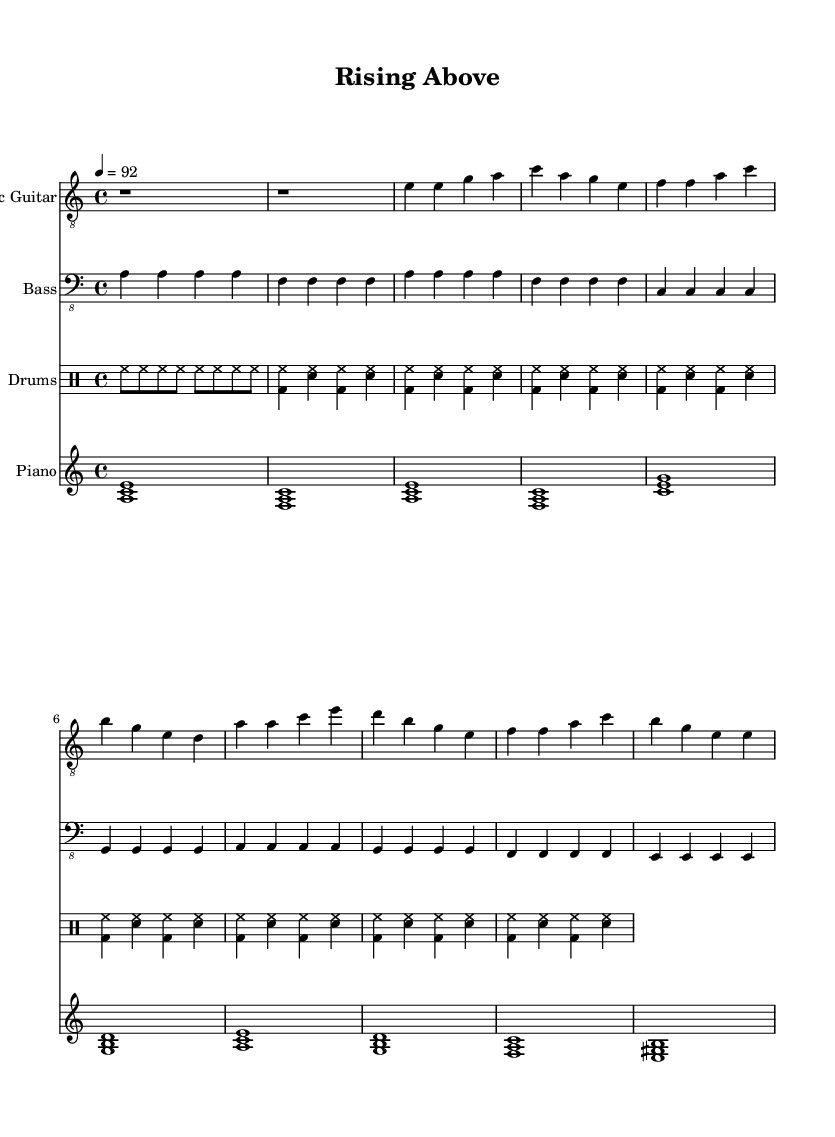What is the key signature of this music? The key signature appears to be A minor, indicated by the absence of sharps and flats, which is characteristic of the relative minor of C major.
Answer: A minor What is the time signature of this piece? The time signature shown in the sheet music is 4/4, which is indicated right at the beginning of the score. This means there are four beats per measure.
Answer: 4/4 What is the tempo marking for this composition? The tempo marking specifies a speed of quarter note equals 92, which is shown in the tempo indication at the beginning of the score.
Answer: 92 How many measures are in the chorus section? By examining the sheet music, the chorus section consists of four measures, as indicated by the groupings of notes under the chorus label.
Answer: 4 What instruments are involved in this arrangement? The sheet music specifies four instruments: Electric Guitar, Bass, Drums, and Piano, as noted in the score headers.
Answer: Electric Guitar, Bass, Drums, Piano How does the bass line in the verse relate to the overall theme? In the verse, the bass line provides a steady foundation using repeated patterns and notes that lead into the contrasting chorus, enhancing the themes of resilience and stability in the music. This interplay between persistence and variation reflects the theme of overcoming challenges.
Answer: Steady foundation What notable chord progression is used in the chorus? The chorus shows a progression starting with the A minor chord, followed by D major, F major, and E major, which creates a sense of movement and emotional depth typical of Electric Blues.
Answer: A minor, D major, F major, E major 